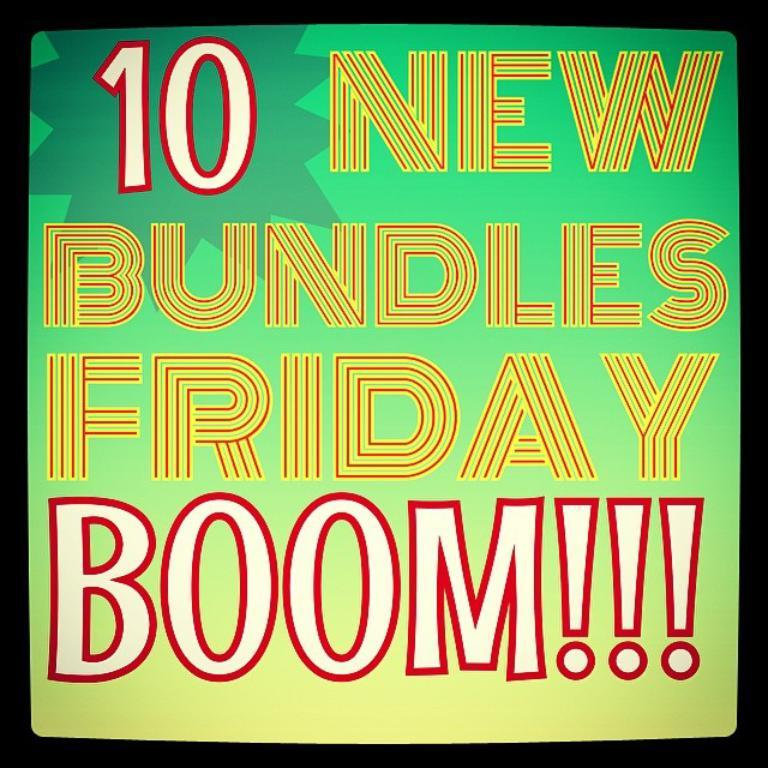<image>
Summarize the visual content of the image. a poster that says '10 new bundles friday boom!' 